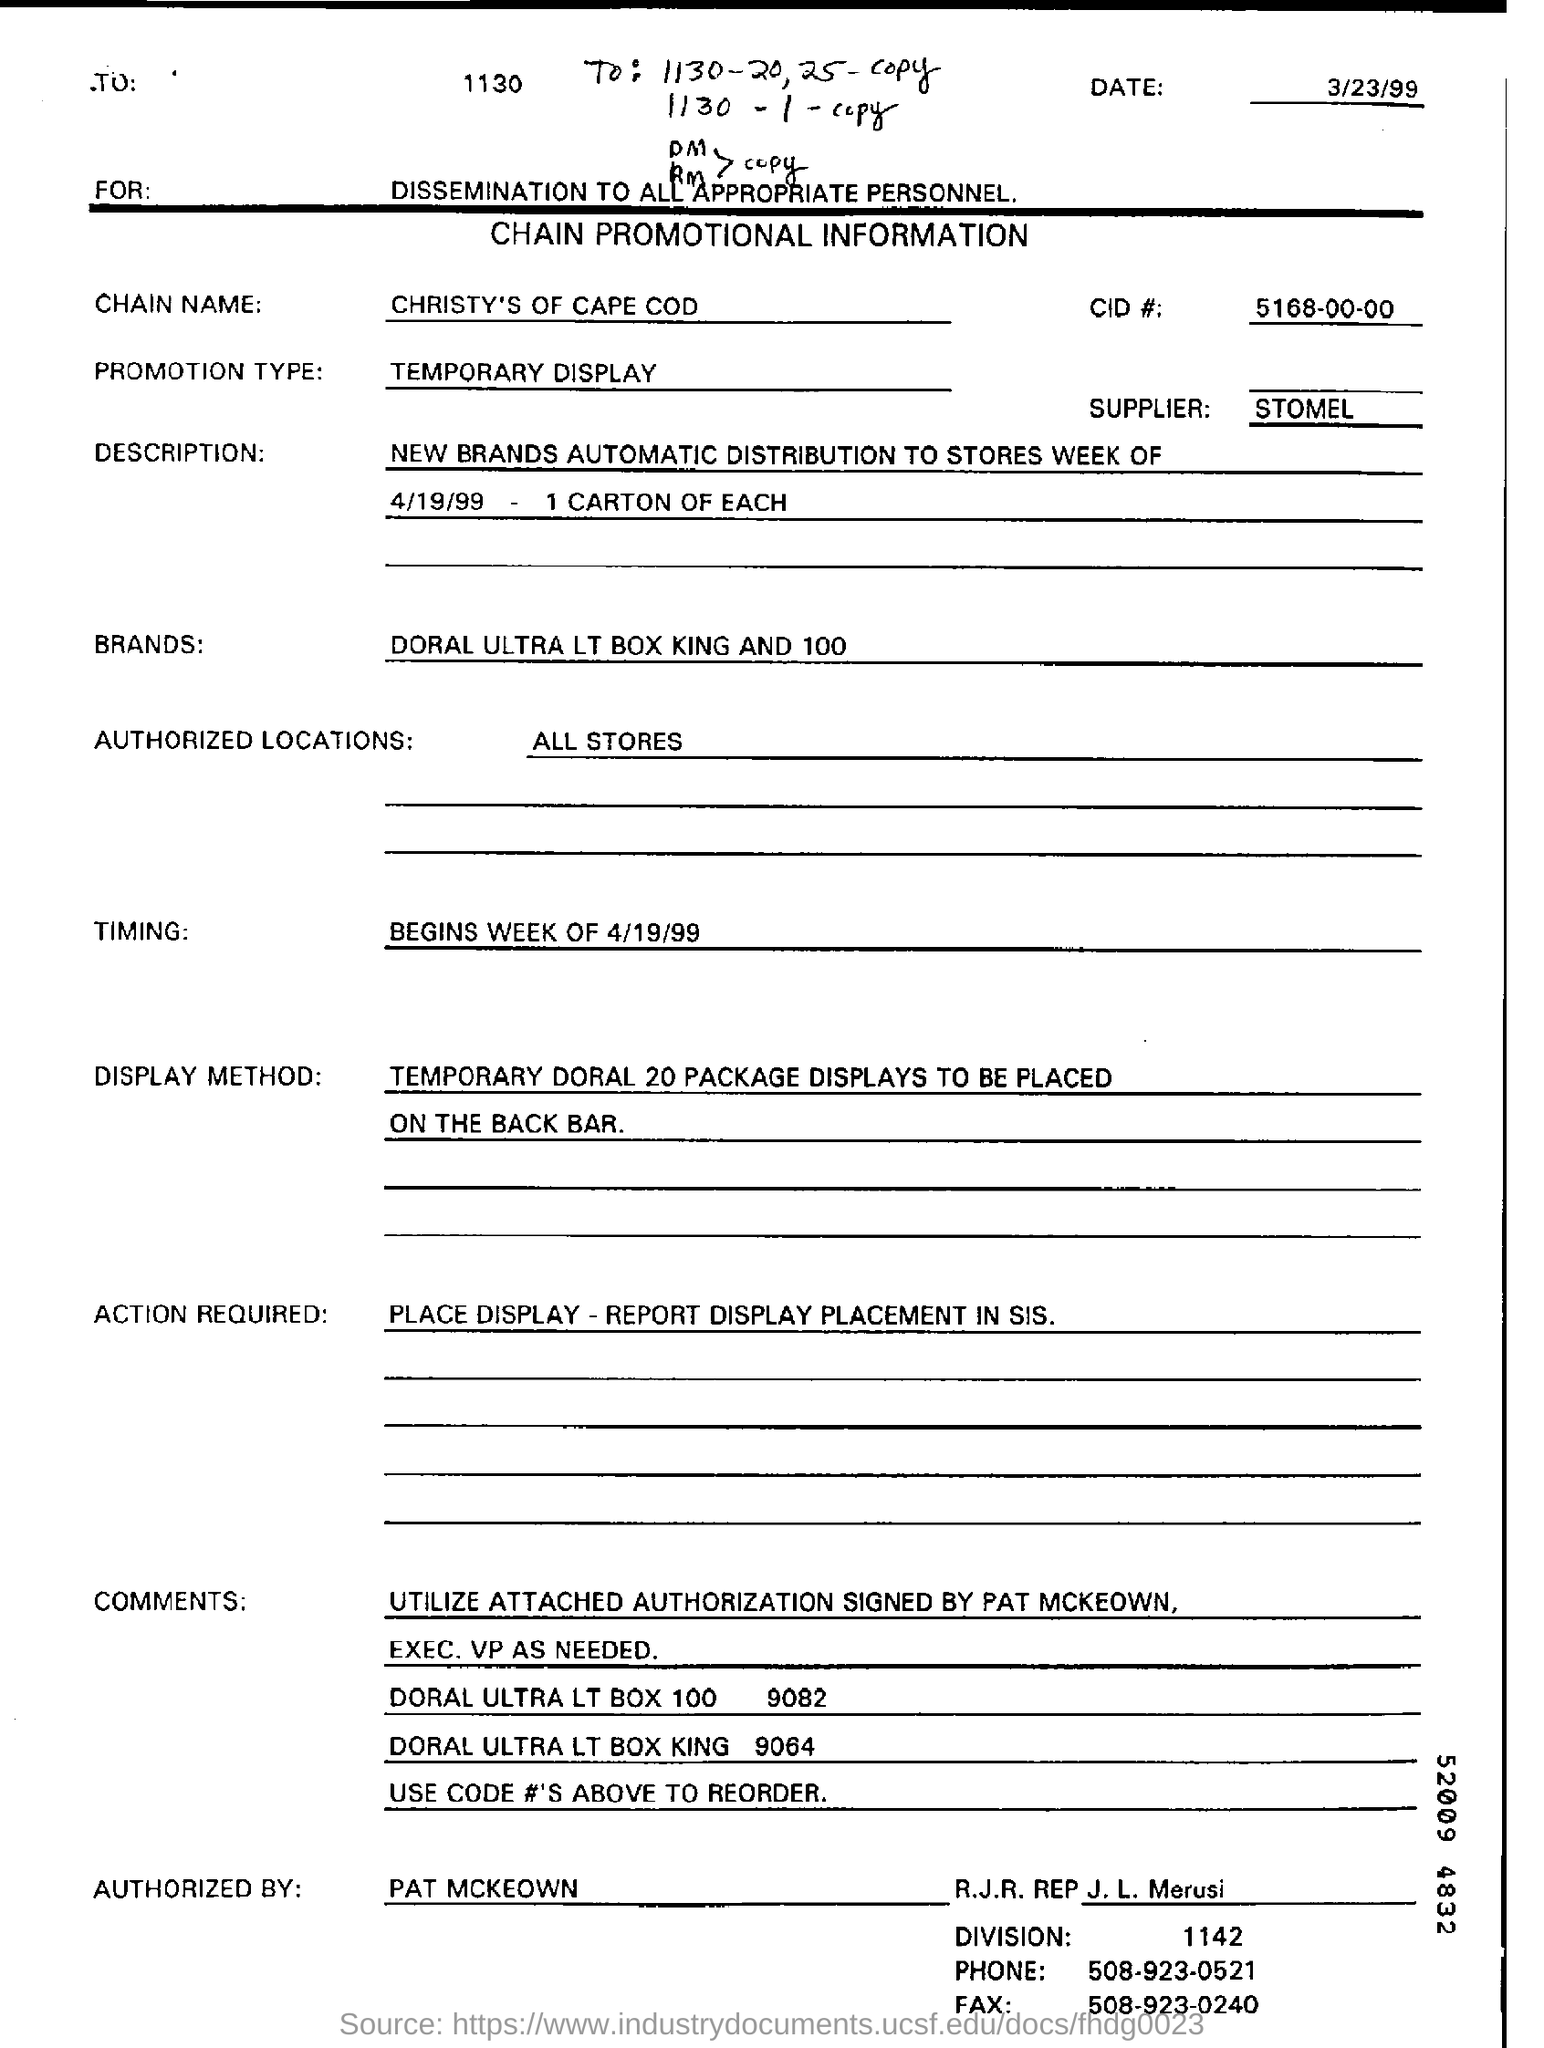When is the document dated?
Your response must be concise. 3/23/99. What type of documentation is this?
Provide a short and direct response. CHAIN PROMOTIONAL INFORMATION. What is the chain name?
Provide a succinct answer. CHRISTY'S OF CAPE COD. What is the CID#?
Ensure brevity in your answer.  5168-00-00. Who is the supplier?
Your answer should be very brief. STOMEL. What is the promotion type?
Offer a terse response. TEMPORARY DISPLAY. What is the action required?
Offer a very short reply. PLACE DISPLAY - REPORT DISPLAY PLACEMENT IN SIS. Who is the form authorized by?
Offer a terse response. PAT MCKEOWN. 